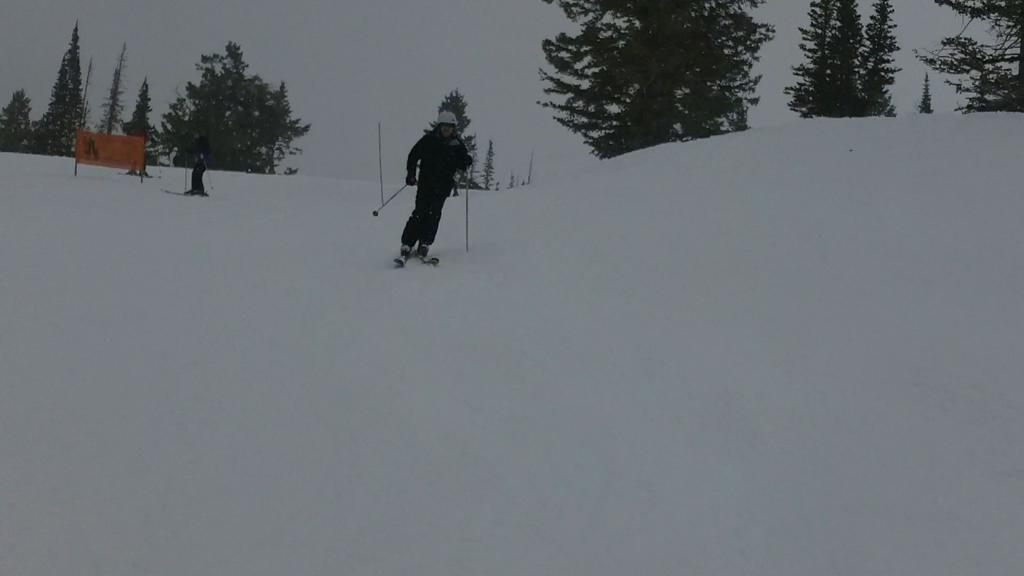What is the setting of the image? The image is taken in a snowy environment. Who is the main subject in the image? There is a person in the center of the image. What is the person doing in the image? The person is skating with ski-boards and holding sticks in their hands. What can be seen in the background of the image? There are trees visible at the top of the image. What is present at the bottom of the image? There is snow at the bottom of the image. What word is being spelled out by the snow at the bottom of the image? There is no word being spelled out by the snow at the bottom of the image. How is the person sorting the waste in the image? There is no waste being sorted in the image; the person is skating with ski-boards and holding sticks. 